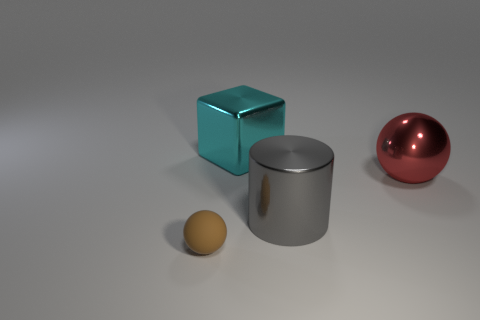Subtract all blocks. How many objects are left? 3 Subtract 2 balls. How many balls are left? 0 Subtract all brown spheres. Subtract all green cylinders. How many spheres are left? 1 Subtract all blue cylinders. How many brown spheres are left? 1 Subtract all gray things. Subtract all red objects. How many objects are left? 2 Add 1 small matte things. How many small matte things are left? 2 Add 3 large gray shiny objects. How many large gray shiny objects exist? 4 Add 2 small blue objects. How many objects exist? 6 Subtract 0 yellow cylinders. How many objects are left? 4 